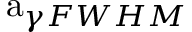Convert formula to latex. <formula><loc_0><loc_0><loc_500><loc_500>a _ { \gamma F W H M }</formula> 